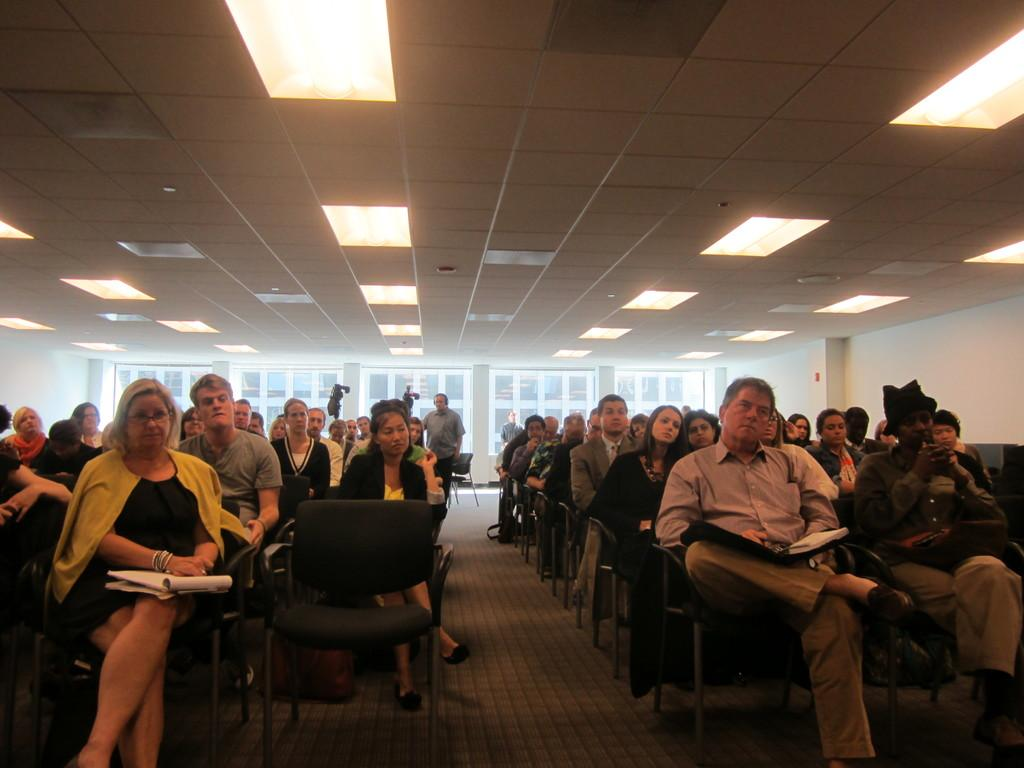What are the people in the image doing? The people in the image are sitting on chairs. Can you describe the background of the image? In the background of the image, there is a man standing and two cameras on stands. What is visible on the ceiling in the image? There are lights visible on the ceiling in the image. What type of polish is being applied to the fowl in the image? There is no fowl or polish present in the image. Can you tell me how many cables are connected to the cameras in the image? The image does not provide enough information to determine how many cables are connected to the cameras. 